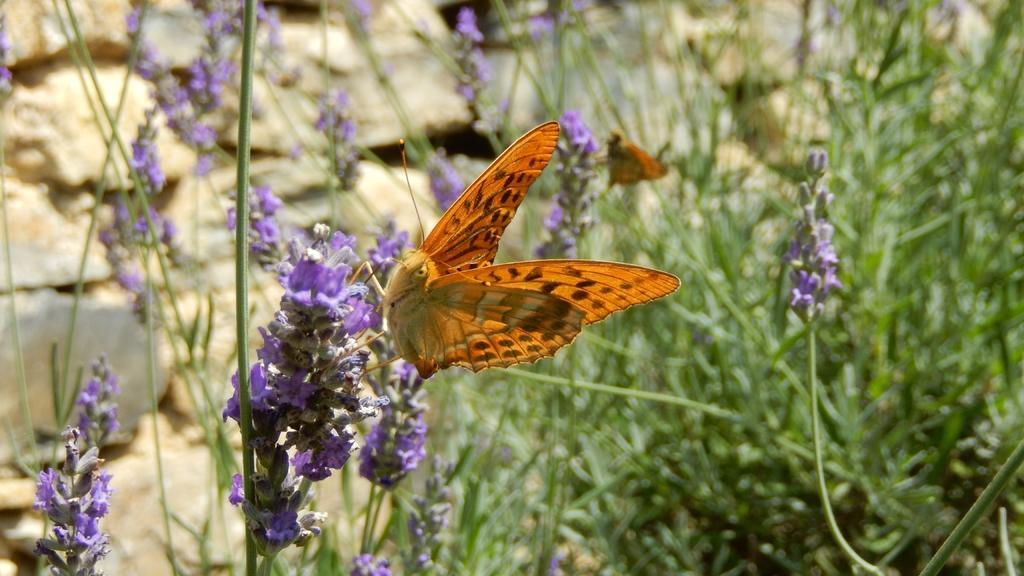What type of plants can be seen on the left side of the image? There are plants with flowers on the left side of the image. What can be seen on the right side of the image? There are other plants on the right side of the image. What is visible in the background of the image? There is a stone wall in the background of the image. How does the basin affect the plants during the rainstorm in the image? There is no basin or rainstorm present in the image; it features plants with flowers on the left side, other plants on the right side, and a stone wall in the background. 